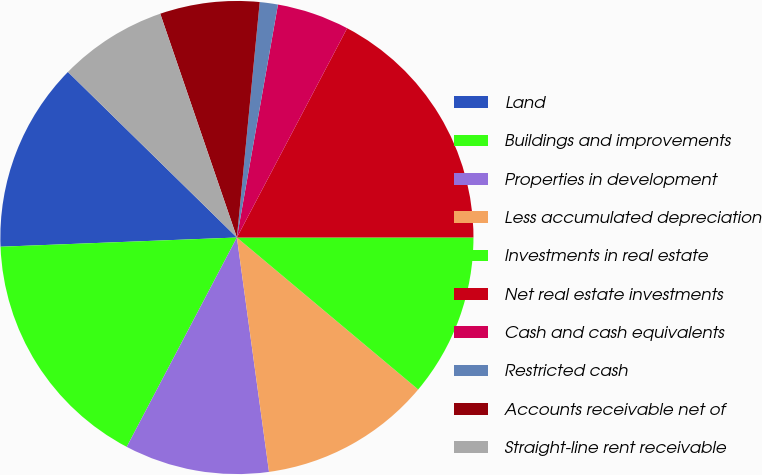Convert chart to OTSL. <chart><loc_0><loc_0><loc_500><loc_500><pie_chart><fcel>Land<fcel>Buildings and improvements<fcel>Properties in development<fcel>Less accumulated depreciation<fcel>Investments in real estate<fcel>Net real estate investments<fcel>Cash and cash equivalents<fcel>Restricted cash<fcel>Accounts receivable net of<fcel>Straight-line rent receivable<nl><fcel>12.96%<fcel>16.67%<fcel>9.88%<fcel>11.73%<fcel>11.11%<fcel>17.28%<fcel>4.94%<fcel>1.24%<fcel>6.79%<fcel>7.41%<nl></chart> 